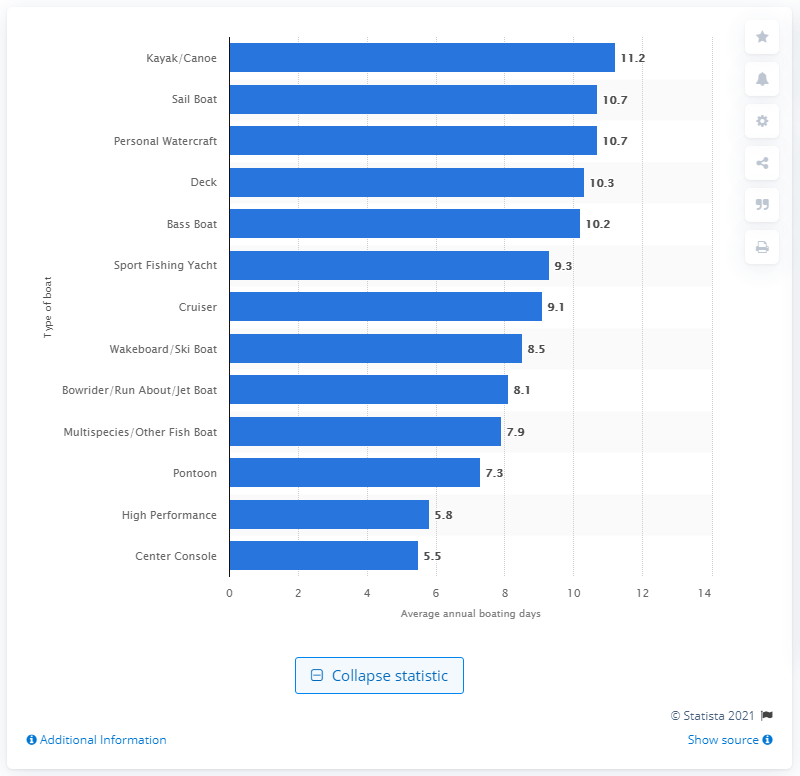List a handful of essential elements in this visual. In 2013, bass boats accounted for an average of 10.2 days of boating among participants in the United States. 